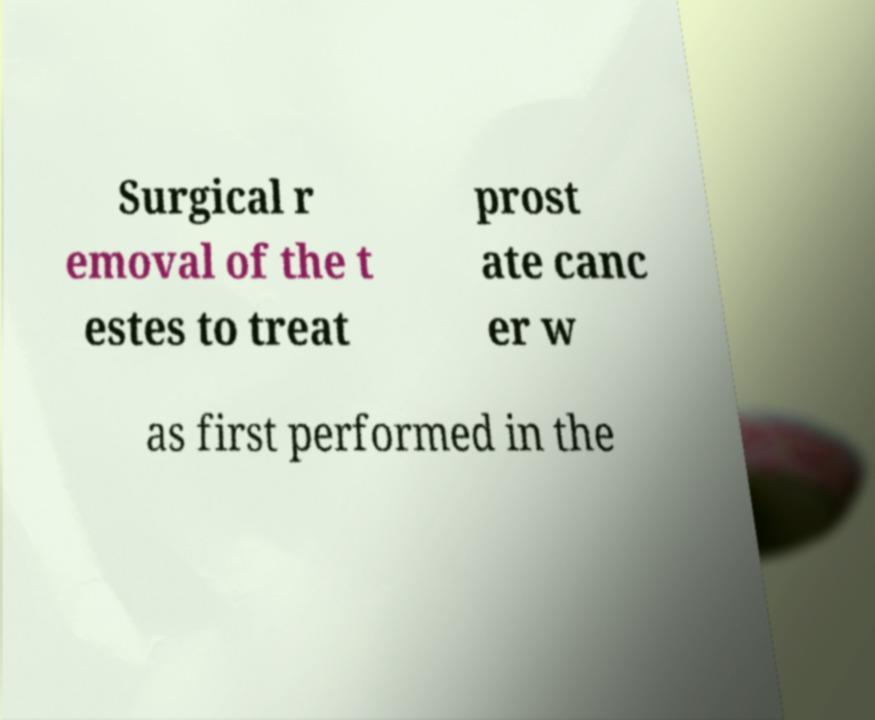Could you assist in decoding the text presented in this image and type it out clearly? Surgical r emoval of the t estes to treat prost ate canc er w as first performed in the 